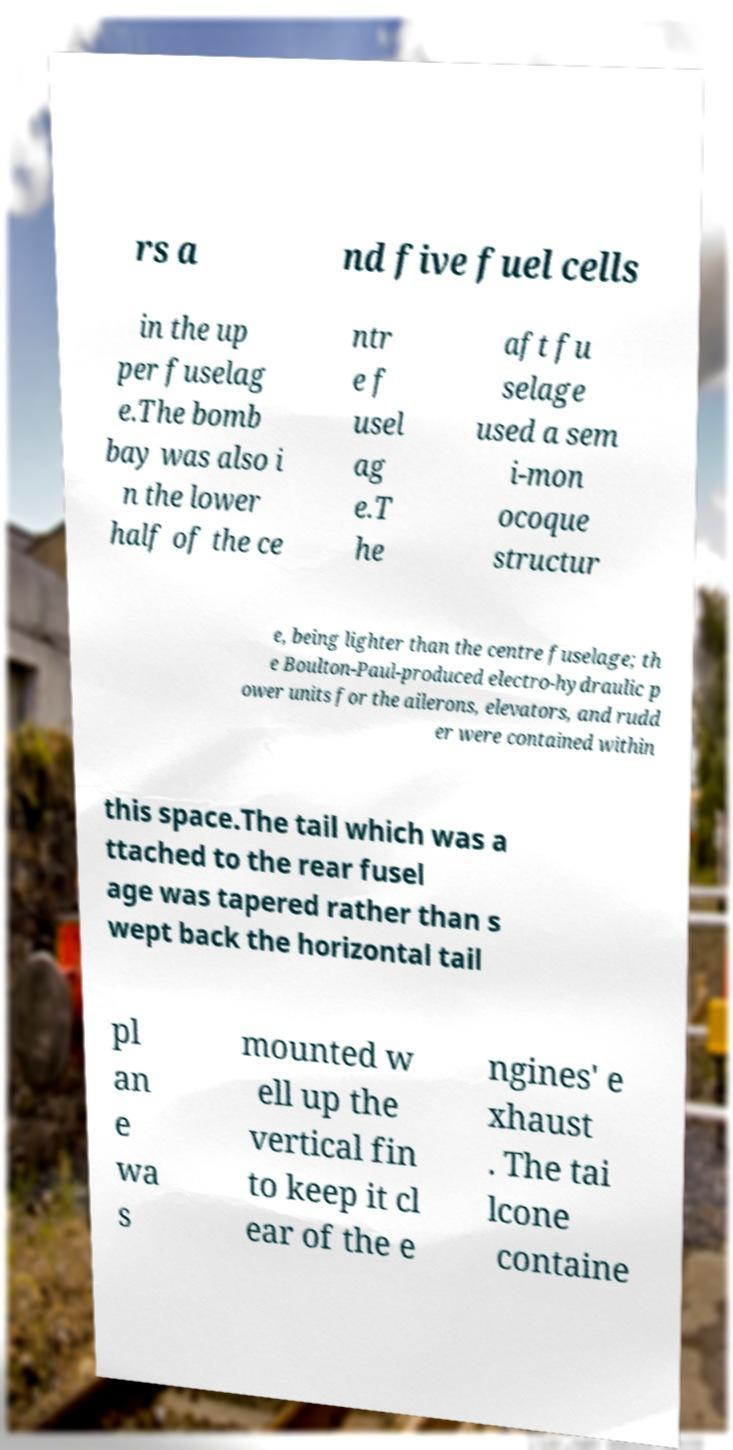Please identify and transcribe the text found in this image. rs a nd five fuel cells in the up per fuselag e.The bomb bay was also i n the lower half of the ce ntr e f usel ag e.T he aft fu selage used a sem i-mon ocoque structur e, being lighter than the centre fuselage; th e Boulton-Paul-produced electro-hydraulic p ower units for the ailerons, elevators, and rudd er were contained within this space.The tail which was a ttached to the rear fusel age was tapered rather than s wept back the horizontal tail pl an e wa s mounted w ell up the vertical fin to keep it cl ear of the e ngines' e xhaust . The tai lcone containe 